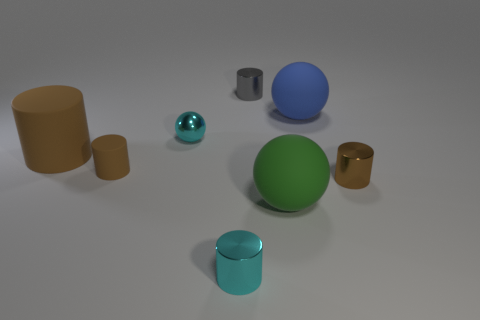Is the shape of the tiny gray object the same as the brown metallic object?
Your answer should be very brief. Yes. Is there any other thing that has the same shape as the small gray object?
Your answer should be compact. Yes. Are any matte cylinders visible?
Make the answer very short. Yes. There is a big green object; does it have the same shape as the tiny brown object that is left of the small metallic ball?
Offer a very short reply. No. There is a tiny brown object that is on the left side of the metallic thing behind the big blue matte thing; what is it made of?
Offer a terse response. Rubber. What is the color of the tiny metal ball?
Your answer should be very brief. Cyan. Does the big matte thing to the left of the tiny gray cylinder have the same color as the small sphere in front of the blue matte ball?
Offer a very short reply. No. What size is the cyan shiny object that is the same shape as the gray object?
Your answer should be very brief. Small. Are there any matte cylinders that have the same color as the tiny sphere?
Offer a very short reply. No. There is another small cylinder that is the same color as the tiny matte cylinder; what is its material?
Provide a short and direct response. Metal. 